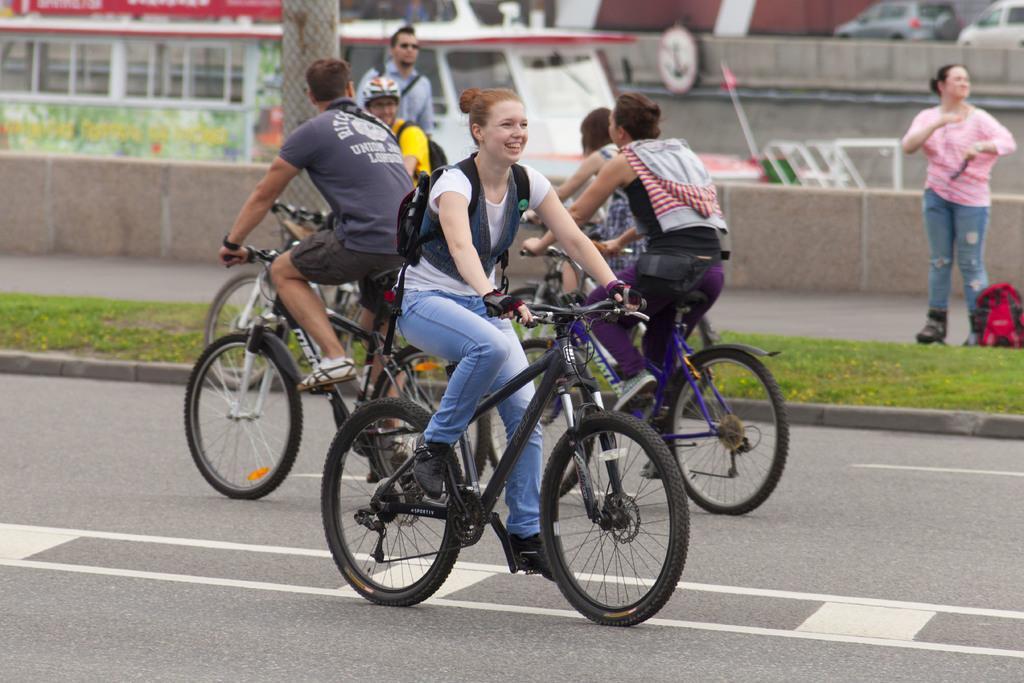Please provide a concise description of this image. In this picture we can see a group of people riding bicycles on road and aside to this road we have grass, woman and man standing, pillar, bus. 